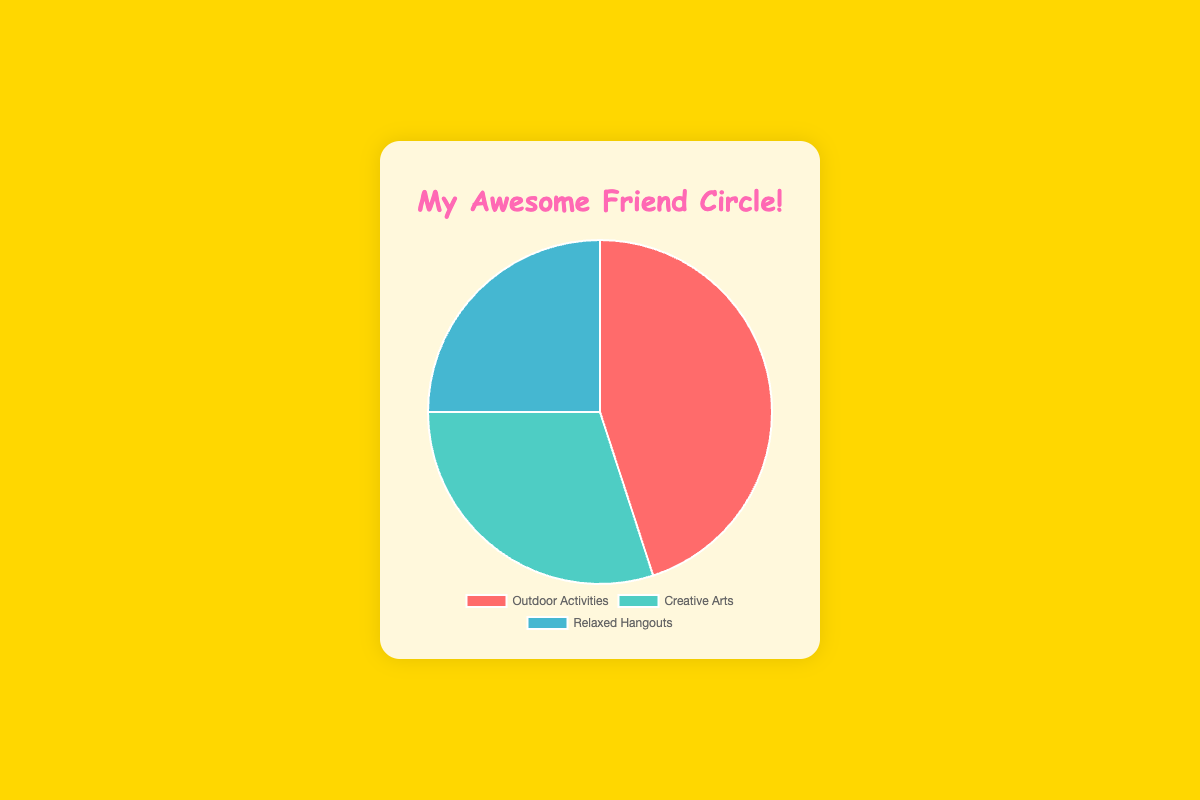What is the most common type of friend based on common interests? The type of friend with the largest percentage in the pie chart represents the most common type. The category "Outdoor Activities" is the largest with 45%.
Answer: Outdoor Activities Which category has the least amount of friends? The smallest section in the pie chart indicates the category with the least amount of friends. "Relaxed Hangouts" occupies the least space with 25%.
Answer: Relaxed Hangouts What is the difference in percentage between friends who enjoy Outdoor Activities and those who prefer Creative Arts? Subtract the percentage of Creative Arts friends from the percentage of Outdoor Activities friends: 45% - 30% = 15%.
Answer: 15% What percentage of friends are involved in either Outdoor Activities or Relaxed Hangouts? Add the percentages of Outdoor Activities and Relaxed Hangouts friends: 45% + 25% = 70%.
Answer: 70% How do the percentages of Creative Arts and Relaxed Hangouts friends compare? Compare the two percentages directly: Creative Arts has 30% and Relaxed Hangouts has 25%, making Creative Arts higher by 5%.
Answer: Creative Arts is higher by 5% Which section of the pie chart is shaded in green? Refer to the visual color coding in the pie chart: the green section corresponds to "Creative Arts".
Answer: Creative Arts If you combine the percentages of friends who enjoy Creative Arts and Relaxed Hangouts, will it exceed the percentage of Outdoor Activities friends? Add the percentages of Creative Arts and Relaxed Hangouts: 30% + 25% = 55%. Since 55% is greater than 45%, it does exceed the percentage of Outdoor Activities friends.
Answer: Yes What is the average percentage of friends across all three categories? Add the percentages of all three categories and divide by the number of categories: (45% + 30% + 25%) / 3 = 33.33%.
Answer: 33.33% Which category represents the second-largest group of friends? The pie chart shows the second-largest section in terms of size and percentage, which is "Creative Arts" at 30%.
Answer: Creative Arts What are the types of friends in the largest category? The largest category by percentage is Outdoor Activities. From the data, the types of friends in this category include "Hikers", "Cycling Enthusiasts", and "Kayakers".
Answer: Hikers, Cycling Enthusiasts, Kayakers 